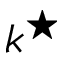Convert formula to latex. <formula><loc_0><loc_0><loc_500><loc_500>k ^ { ^ { * } }</formula> 